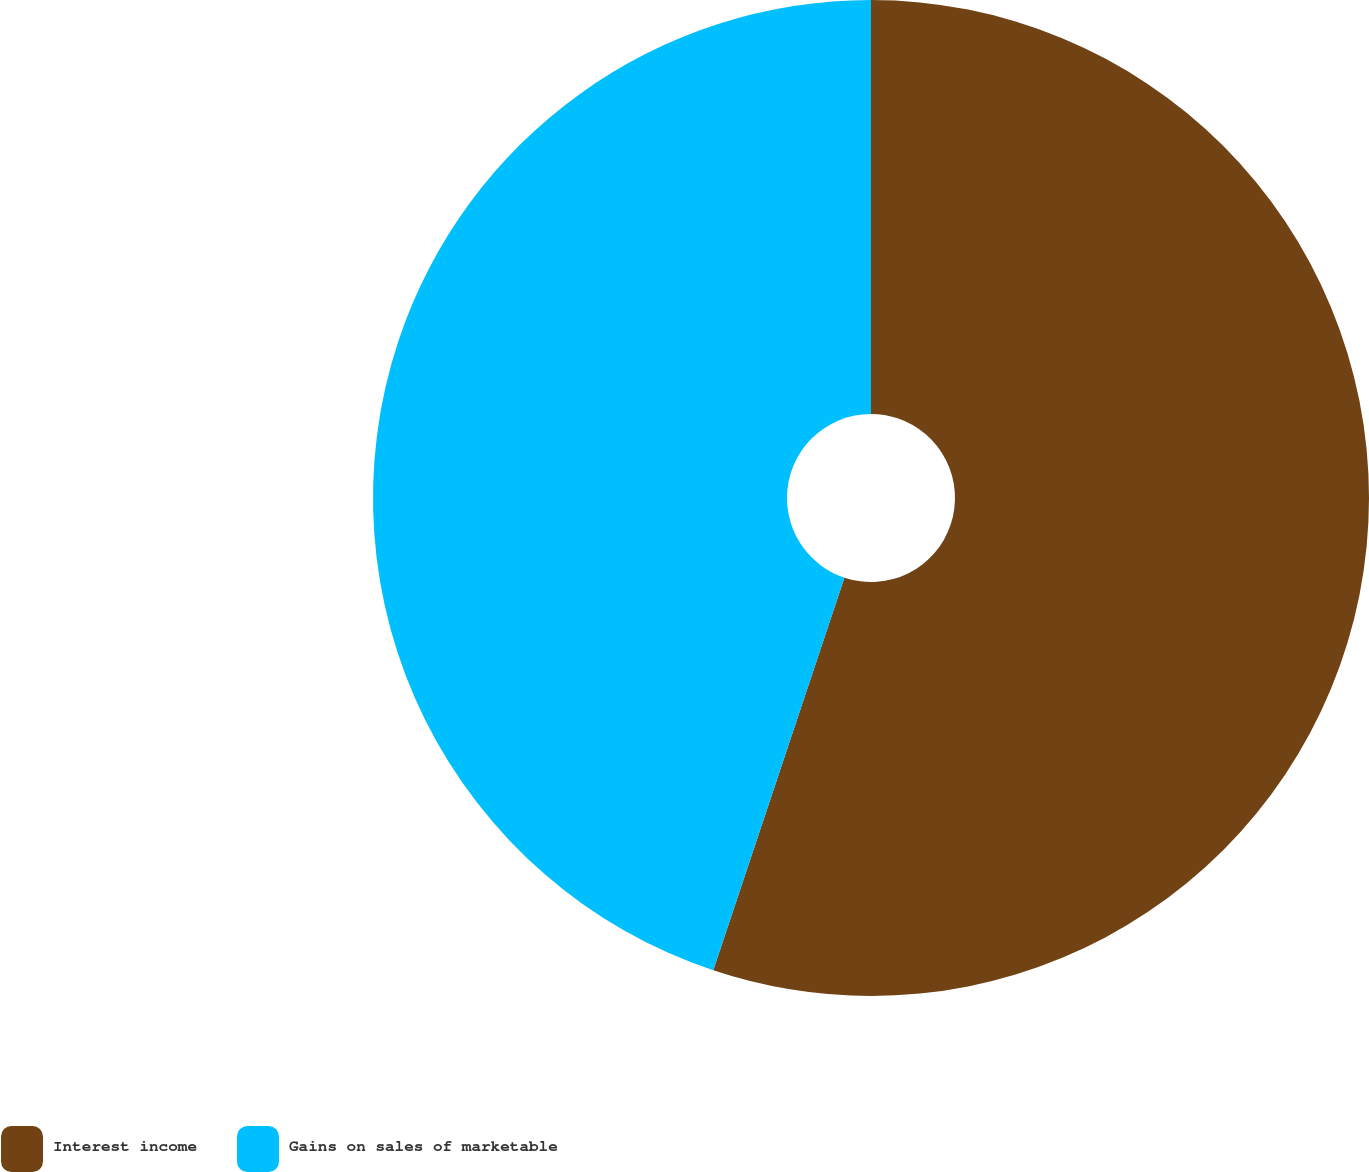Convert chart to OTSL. <chart><loc_0><loc_0><loc_500><loc_500><pie_chart><fcel>Interest income<fcel>Gains on sales of marketable<nl><fcel>55.13%<fcel>44.87%<nl></chart> 